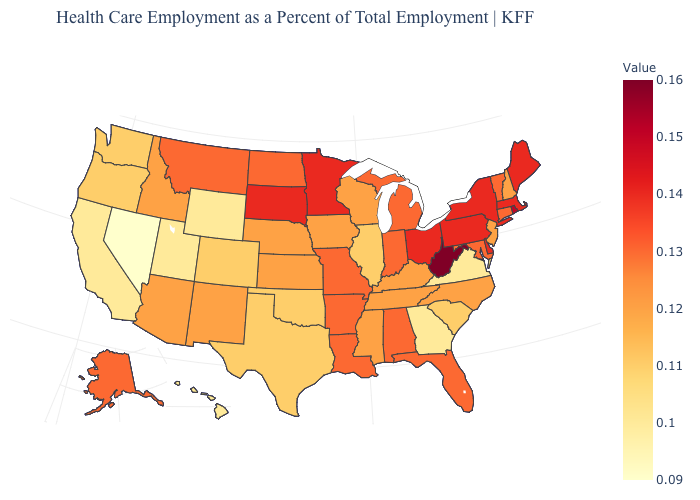Which states have the lowest value in the MidWest?
Keep it brief. Illinois. Does Kentucky have the lowest value in the USA?
Give a very brief answer. No. Does West Virginia have the highest value in the South?
Write a very short answer. Yes. Among the states that border Kansas , which have the lowest value?
Be succinct. Colorado, Oklahoma. Which states have the highest value in the USA?
Short answer required. West Virginia. Does Georgia have the lowest value in the South?
Short answer required. Yes. Does Tennessee have the lowest value in the South?
Short answer required. No. 